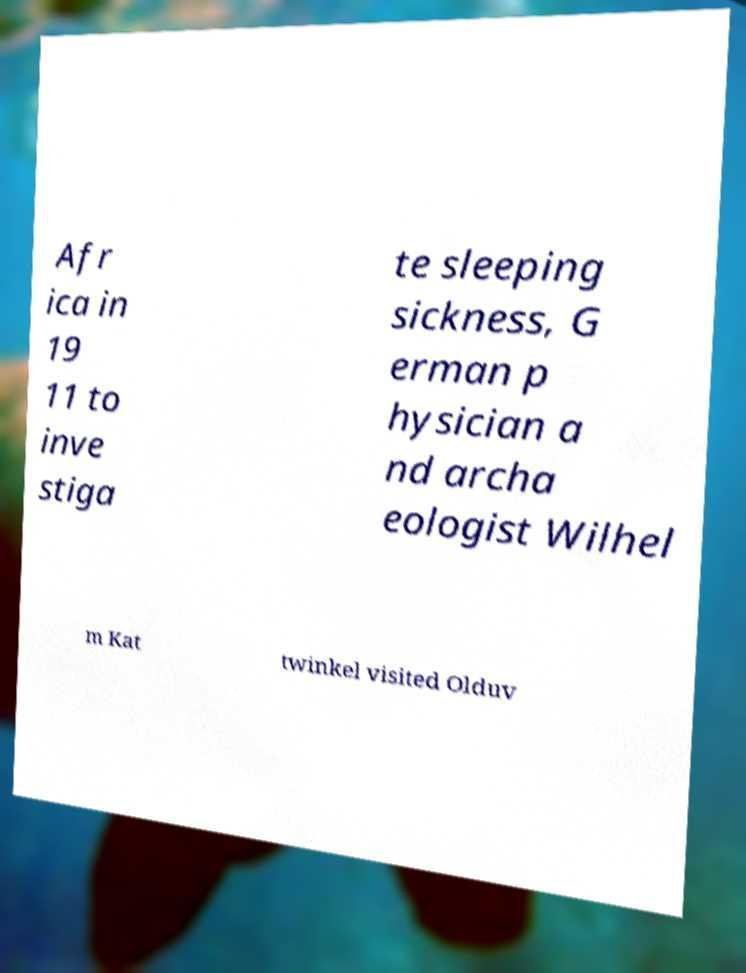There's text embedded in this image that I need extracted. Can you transcribe it verbatim? Afr ica in 19 11 to inve stiga te sleeping sickness, G erman p hysician a nd archa eologist Wilhel m Kat twinkel visited Olduv 